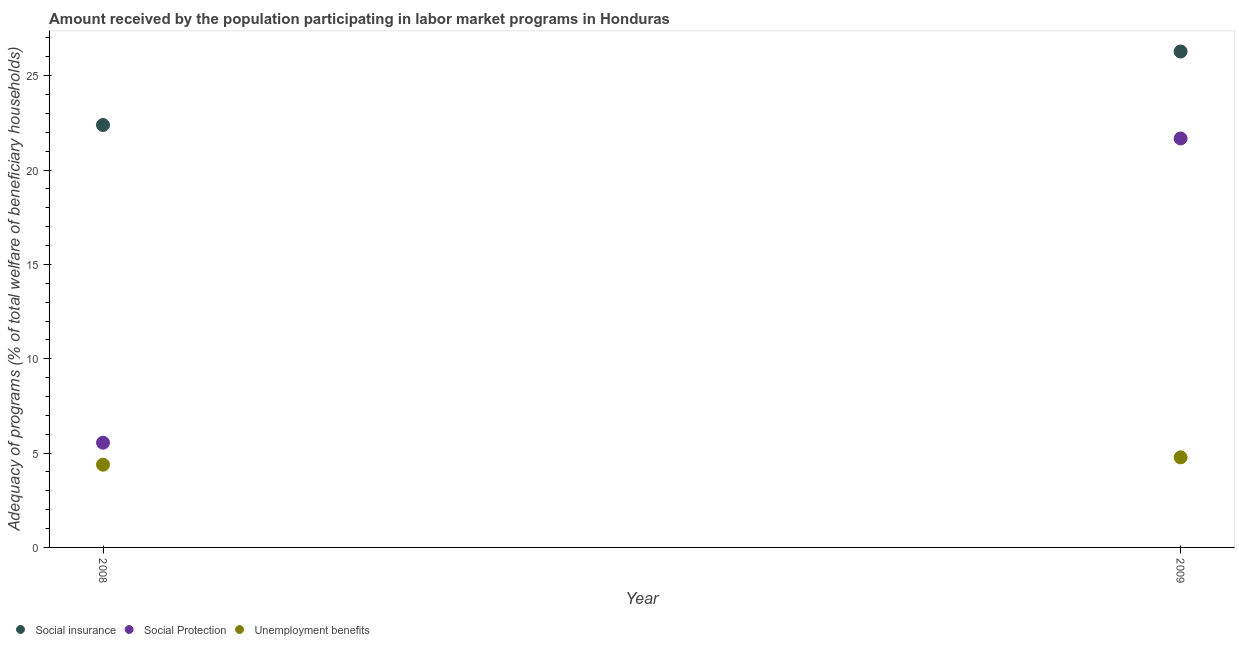How many different coloured dotlines are there?
Give a very brief answer. 3. What is the amount received by the population participating in social protection programs in 2008?
Offer a very short reply. 5.55. Across all years, what is the maximum amount received by the population participating in unemployment benefits programs?
Provide a succinct answer. 4.77. Across all years, what is the minimum amount received by the population participating in social protection programs?
Your response must be concise. 5.55. In which year was the amount received by the population participating in unemployment benefits programs maximum?
Offer a terse response. 2009. What is the total amount received by the population participating in social insurance programs in the graph?
Provide a succinct answer. 48.67. What is the difference between the amount received by the population participating in social protection programs in 2008 and that in 2009?
Keep it short and to the point. -16.12. What is the difference between the amount received by the population participating in unemployment benefits programs in 2009 and the amount received by the population participating in social insurance programs in 2008?
Offer a terse response. -17.61. What is the average amount received by the population participating in social protection programs per year?
Keep it short and to the point. 13.61. In the year 2008, what is the difference between the amount received by the population participating in social protection programs and amount received by the population participating in unemployment benefits programs?
Provide a succinct answer. 1.16. What is the ratio of the amount received by the population participating in social protection programs in 2008 to that in 2009?
Your response must be concise. 0.26. Is the amount received by the population participating in social protection programs in 2008 less than that in 2009?
Your answer should be compact. Yes. In how many years, is the amount received by the population participating in social insurance programs greater than the average amount received by the population participating in social insurance programs taken over all years?
Your response must be concise. 1. Does the amount received by the population participating in unemployment benefits programs monotonically increase over the years?
Offer a very short reply. Yes. Is the amount received by the population participating in social protection programs strictly less than the amount received by the population participating in social insurance programs over the years?
Your answer should be very brief. Yes. How many dotlines are there?
Your answer should be compact. 3. How many years are there in the graph?
Your response must be concise. 2. How many legend labels are there?
Give a very brief answer. 3. What is the title of the graph?
Offer a terse response. Amount received by the population participating in labor market programs in Honduras. Does "Wage workers" appear as one of the legend labels in the graph?
Keep it short and to the point. No. What is the label or title of the X-axis?
Offer a very short reply. Year. What is the label or title of the Y-axis?
Make the answer very short. Adequacy of programs (% of total welfare of beneficiary households). What is the Adequacy of programs (% of total welfare of beneficiary households) of Social insurance in 2008?
Provide a succinct answer. 22.39. What is the Adequacy of programs (% of total welfare of beneficiary households) of Social Protection in 2008?
Provide a short and direct response. 5.55. What is the Adequacy of programs (% of total welfare of beneficiary households) of Unemployment benefits in 2008?
Keep it short and to the point. 4.39. What is the Adequacy of programs (% of total welfare of beneficiary households) of Social insurance in 2009?
Your answer should be compact. 26.28. What is the Adequacy of programs (% of total welfare of beneficiary households) of Social Protection in 2009?
Offer a terse response. 21.67. What is the Adequacy of programs (% of total welfare of beneficiary households) in Unemployment benefits in 2009?
Provide a short and direct response. 4.77. Across all years, what is the maximum Adequacy of programs (% of total welfare of beneficiary households) of Social insurance?
Offer a terse response. 26.28. Across all years, what is the maximum Adequacy of programs (% of total welfare of beneficiary households) of Social Protection?
Make the answer very short. 21.67. Across all years, what is the maximum Adequacy of programs (% of total welfare of beneficiary households) of Unemployment benefits?
Give a very brief answer. 4.77. Across all years, what is the minimum Adequacy of programs (% of total welfare of beneficiary households) of Social insurance?
Keep it short and to the point. 22.39. Across all years, what is the minimum Adequacy of programs (% of total welfare of beneficiary households) in Social Protection?
Provide a short and direct response. 5.55. Across all years, what is the minimum Adequacy of programs (% of total welfare of beneficiary households) in Unemployment benefits?
Your answer should be very brief. 4.39. What is the total Adequacy of programs (% of total welfare of beneficiary households) in Social insurance in the graph?
Keep it short and to the point. 48.67. What is the total Adequacy of programs (% of total welfare of beneficiary households) of Social Protection in the graph?
Your answer should be compact. 27.22. What is the total Adequacy of programs (% of total welfare of beneficiary households) in Unemployment benefits in the graph?
Make the answer very short. 9.16. What is the difference between the Adequacy of programs (% of total welfare of beneficiary households) of Social insurance in 2008 and that in 2009?
Ensure brevity in your answer.  -3.9. What is the difference between the Adequacy of programs (% of total welfare of beneficiary households) in Social Protection in 2008 and that in 2009?
Your answer should be very brief. -16.12. What is the difference between the Adequacy of programs (% of total welfare of beneficiary households) in Unemployment benefits in 2008 and that in 2009?
Provide a succinct answer. -0.39. What is the difference between the Adequacy of programs (% of total welfare of beneficiary households) of Social insurance in 2008 and the Adequacy of programs (% of total welfare of beneficiary households) of Social Protection in 2009?
Make the answer very short. 0.71. What is the difference between the Adequacy of programs (% of total welfare of beneficiary households) in Social insurance in 2008 and the Adequacy of programs (% of total welfare of beneficiary households) in Unemployment benefits in 2009?
Provide a succinct answer. 17.61. What is the difference between the Adequacy of programs (% of total welfare of beneficiary households) in Social Protection in 2008 and the Adequacy of programs (% of total welfare of beneficiary households) in Unemployment benefits in 2009?
Provide a short and direct response. 0.78. What is the average Adequacy of programs (% of total welfare of beneficiary households) of Social insurance per year?
Your response must be concise. 24.34. What is the average Adequacy of programs (% of total welfare of beneficiary households) in Social Protection per year?
Offer a very short reply. 13.61. What is the average Adequacy of programs (% of total welfare of beneficiary households) of Unemployment benefits per year?
Your answer should be compact. 4.58. In the year 2008, what is the difference between the Adequacy of programs (% of total welfare of beneficiary households) in Social insurance and Adequacy of programs (% of total welfare of beneficiary households) in Social Protection?
Your response must be concise. 16.84. In the year 2008, what is the difference between the Adequacy of programs (% of total welfare of beneficiary households) in Social insurance and Adequacy of programs (% of total welfare of beneficiary households) in Unemployment benefits?
Provide a succinct answer. 18. In the year 2008, what is the difference between the Adequacy of programs (% of total welfare of beneficiary households) of Social Protection and Adequacy of programs (% of total welfare of beneficiary households) of Unemployment benefits?
Make the answer very short. 1.17. In the year 2009, what is the difference between the Adequacy of programs (% of total welfare of beneficiary households) in Social insurance and Adequacy of programs (% of total welfare of beneficiary households) in Social Protection?
Offer a very short reply. 4.61. In the year 2009, what is the difference between the Adequacy of programs (% of total welfare of beneficiary households) in Social insurance and Adequacy of programs (% of total welfare of beneficiary households) in Unemployment benefits?
Provide a succinct answer. 21.51. In the year 2009, what is the difference between the Adequacy of programs (% of total welfare of beneficiary households) of Social Protection and Adequacy of programs (% of total welfare of beneficiary households) of Unemployment benefits?
Your answer should be very brief. 16.9. What is the ratio of the Adequacy of programs (% of total welfare of beneficiary households) of Social insurance in 2008 to that in 2009?
Offer a terse response. 0.85. What is the ratio of the Adequacy of programs (% of total welfare of beneficiary households) of Social Protection in 2008 to that in 2009?
Offer a very short reply. 0.26. What is the ratio of the Adequacy of programs (% of total welfare of beneficiary households) in Unemployment benefits in 2008 to that in 2009?
Give a very brief answer. 0.92. What is the difference between the highest and the second highest Adequacy of programs (% of total welfare of beneficiary households) of Social insurance?
Offer a very short reply. 3.9. What is the difference between the highest and the second highest Adequacy of programs (% of total welfare of beneficiary households) of Social Protection?
Ensure brevity in your answer.  16.12. What is the difference between the highest and the second highest Adequacy of programs (% of total welfare of beneficiary households) of Unemployment benefits?
Offer a very short reply. 0.39. What is the difference between the highest and the lowest Adequacy of programs (% of total welfare of beneficiary households) of Social insurance?
Your answer should be very brief. 3.9. What is the difference between the highest and the lowest Adequacy of programs (% of total welfare of beneficiary households) in Social Protection?
Provide a succinct answer. 16.12. What is the difference between the highest and the lowest Adequacy of programs (% of total welfare of beneficiary households) in Unemployment benefits?
Your answer should be very brief. 0.39. 